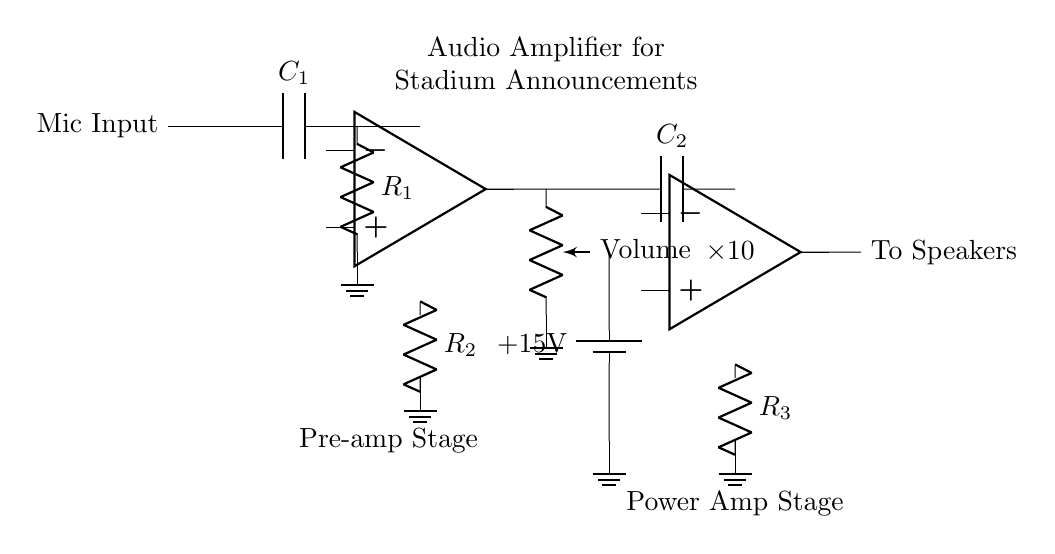What is the first component in the circuit? The first component in the circuit is a microphone input, which is represented at the beginning of the diagram where sounds are converted to electrical signals.
Answer: Mic Input What is the purpose of the capacitor labeled C1? Capacitor C1 is used for coupling AC signals while blocking DC. In audio amplifiers, this helps to prevent any unwanted DC offset from affecting the subsequent stages of the circuit.
Answer: Coupling What is the gain of the second op-amp in this circuit? The gain of the second op-amp is indicated to be 10, meaning that it amplifies the input signal by a factor of ten before sending it to the speakers.
Answer: 10 What type of amplifier is shown in the circuit? The circuit is identified as an audio amplifier, specifically designed for amplifying audio signals for stadium announcements.
Answer: Audio amplifier Which component is used for volume control? The component designated for volume control in the circuit is a potentiometer that adjusts the level of the audio signal before further amplification.
Answer: Volume What do the two resistors R1 and R3 represent in this circuit? R1 is part of the pre-amplifier stage influencing gain and input impedance, while R3 is in the power amplifier stage, also affecting gain and load characteristics of the output signal to the speakers.
Answer: Gain control What power voltage is supplied to the circuit? The circuit is powered by a positive voltage of plus fifteen volts which is necessary for the op-amps to function correctly and amplify the audio signal.
Answer: 15 volts 